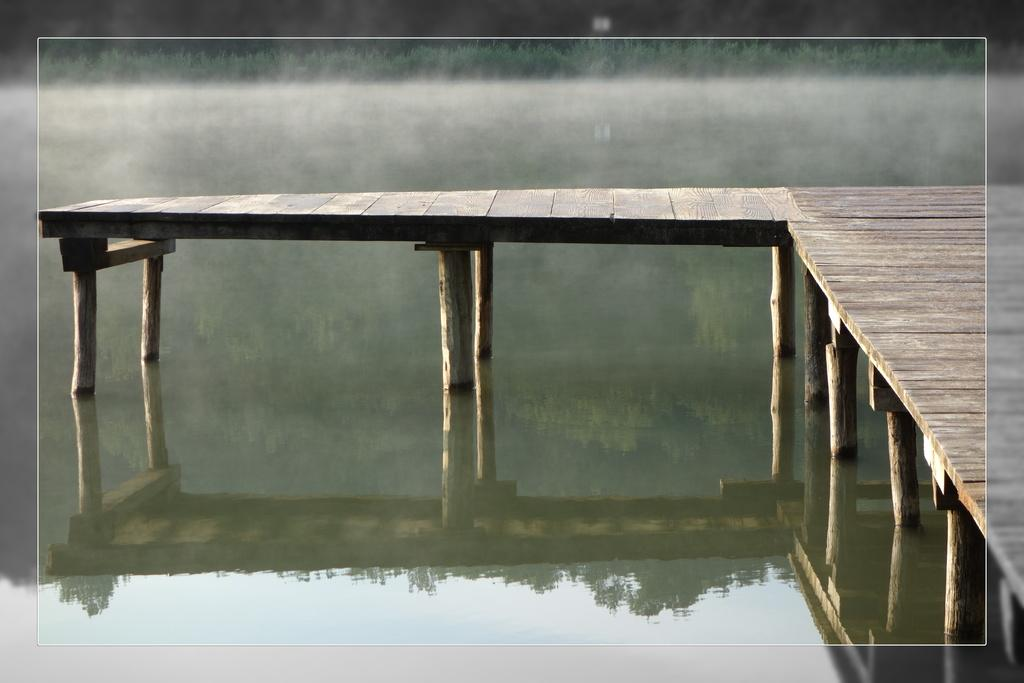What type of structure is present in the image? There is a wooden bridge in the image. What can be seen in the background of the image? There is water visible in the background of the image. How many babies are holding hands on the wooden bridge in the image? There are no babies present in the image, and therefore no hand-holding can be observed. 